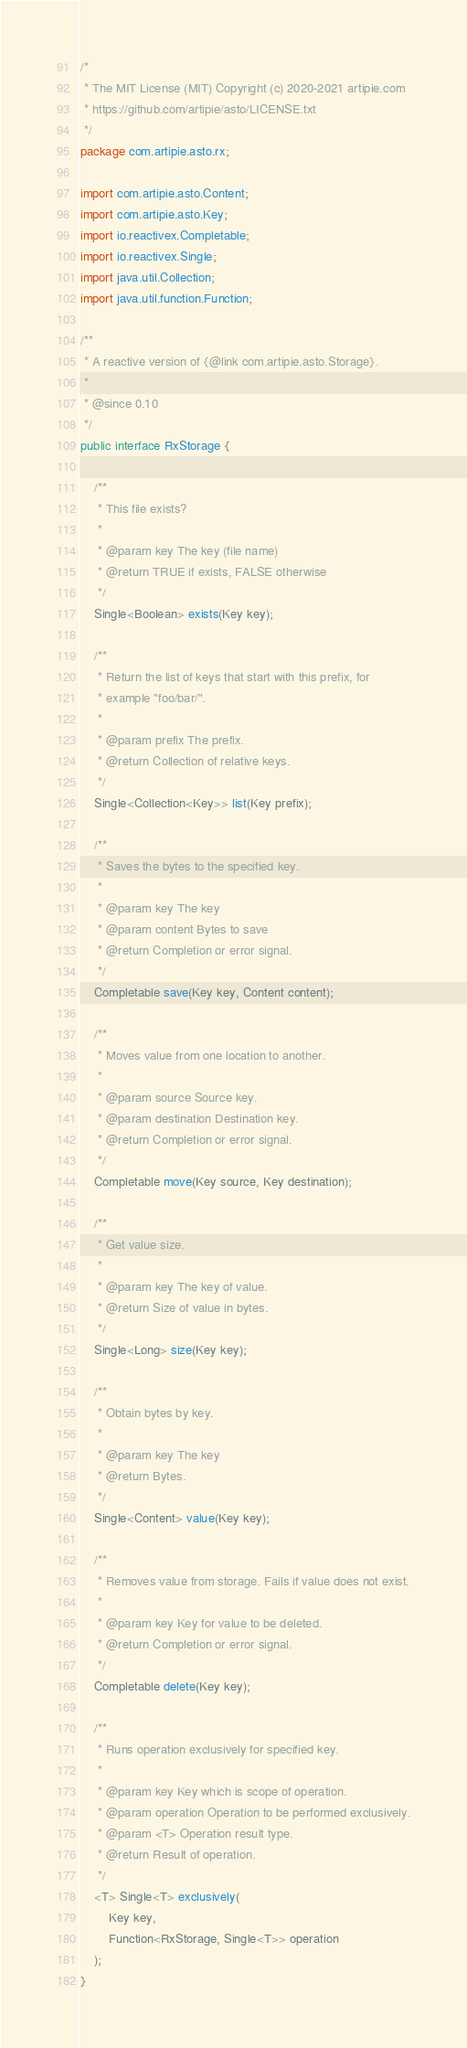<code> <loc_0><loc_0><loc_500><loc_500><_Java_>/*
 * The MIT License (MIT) Copyright (c) 2020-2021 artipie.com
 * https://github.com/artipie/asto/LICENSE.txt
 */
package com.artipie.asto.rx;

import com.artipie.asto.Content;
import com.artipie.asto.Key;
import io.reactivex.Completable;
import io.reactivex.Single;
import java.util.Collection;
import java.util.function.Function;

/**
 * A reactive version of {@link com.artipie.asto.Storage}.
 *
 * @since 0.10
 */
public interface RxStorage {

    /**
     * This file exists?
     *
     * @param key The key (file name)
     * @return TRUE if exists, FALSE otherwise
     */
    Single<Boolean> exists(Key key);

    /**
     * Return the list of keys that start with this prefix, for
     * example "foo/bar/".
     *
     * @param prefix The prefix.
     * @return Collection of relative keys.
     */
    Single<Collection<Key>> list(Key prefix);

    /**
     * Saves the bytes to the specified key.
     *
     * @param key The key
     * @param content Bytes to save
     * @return Completion or error signal.
     */
    Completable save(Key key, Content content);

    /**
     * Moves value from one location to another.
     *
     * @param source Source key.
     * @param destination Destination key.
     * @return Completion or error signal.
     */
    Completable move(Key source, Key destination);

    /**
     * Get value size.
     *
     * @param key The key of value.
     * @return Size of value in bytes.
     */
    Single<Long> size(Key key);

    /**
     * Obtain bytes by key.
     *
     * @param key The key
     * @return Bytes.
     */
    Single<Content> value(Key key);

    /**
     * Removes value from storage. Fails if value does not exist.
     *
     * @param key Key for value to be deleted.
     * @return Completion or error signal.
     */
    Completable delete(Key key);

    /**
     * Runs operation exclusively for specified key.
     *
     * @param key Key which is scope of operation.
     * @param operation Operation to be performed exclusively.
     * @param <T> Operation result type.
     * @return Result of operation.
     */
    <T> Single<T> exclusively(
        Key key,
        Function<RxStorage, Single<T>> operation
    );
}
</code> 